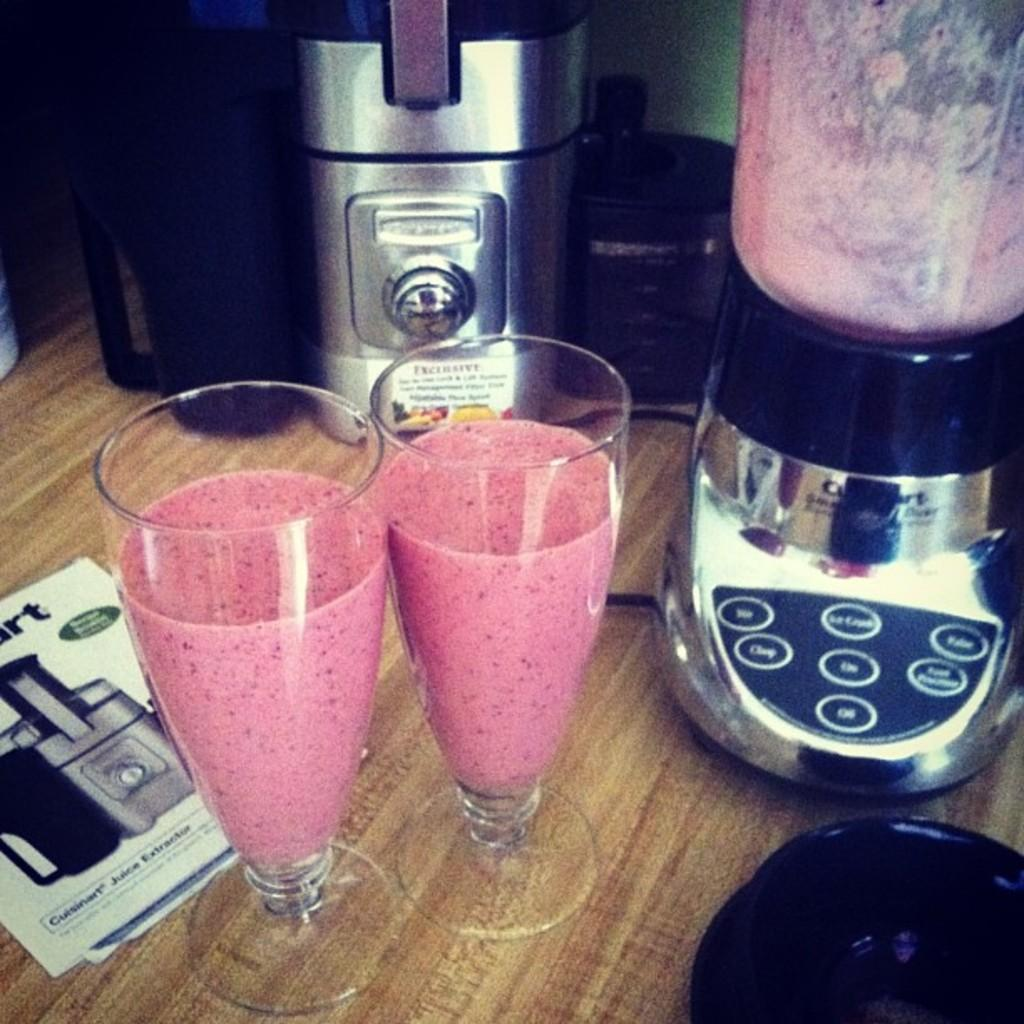Provide a one-sentence caption for the provided image. Two smoothies are on a table next to a Cuisinart juice extractor. 